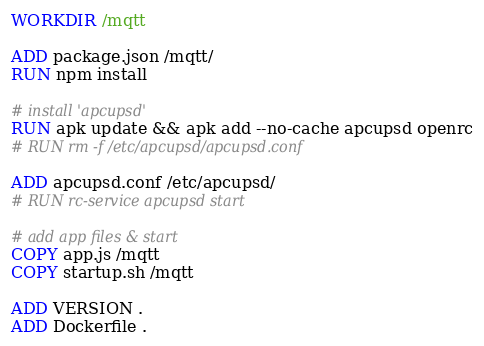<code> <loc_0><loc_0><loc_500><loc_500><_Dockerfile_>WORKDIR /mqtt

ADD package.json /mqtt/
RUN npm install

# install 'apcupsd'
RUN apk update && apk add --no-cache apcupsd openrc
# RUN rm -f /etc/apcupsd/apcupsd.conf

ADD apcupsd.conf /etc/apcupsd/
# RUN rc-service apcupsd start

# add app files & start
COPY app.js /mqtt
COPY startup.sh /mqtt

ADD VERSION .
ADD Dockerfile .</code> 